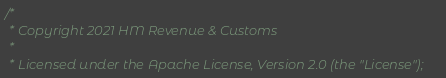<code> <loc_0><loc_0><loc_500><loc_500><_Scala_>/*
 * Copyright 2021 HM Revenue & Customs
 *
 * Licensed under the Apache License, Version 2.0 (the "License");</code> 